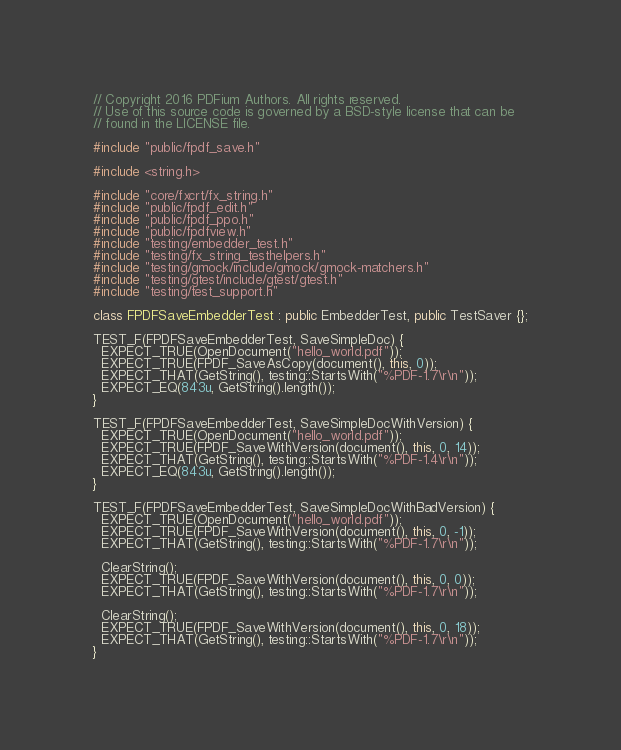<code> <loc_0><loc_0><loc_500><loc_500><_C++_>// Copyright 2016 PDFium Authors. All rights reserved.
// Use of this source code is governed by a BSD-style license that can be
// found in the LICENSE file.

#include "public/fpdf_save.h"

#include <string.h>

#include "core/fxcrt/fx_string.h"
#include "public/fpdf_edit.h"
#include "public/fpdf_ppo.h"
#include "public/fpdfview.h"
#include "testing/embedder_test.h"
#include "testing/fx_string_testhelpers.h"
#include "testing/gmock/include/gmock/gmock-matchers.h"
#include "testing/gtest/include/gtest/gtest.h"
#include "testing/test_support.h"

class FPDFSaveEmbedderTest : public EmbedderTest, public TestSaver {};

TEST_F(FPDFSaveEmbedderTest, SaveSimpleDoc) {
  EXPECT_TRUE(OpenDocument("hello_world.pdf"));
  EXPECT_TRUE(FPDF_SaveAsCopy(document(), this, 0));
  EXPECT_THAT(GetString(), testing::StartsWith("%PDF-1.7\r\n"));
  EXPECT_EQ(843u, GetString().length());
}

TEST_F(FPDFSaveEmbedderTest, SaveSimpleDocWithVersion) {
  EXPECT_TRUE(OpenDocument("hello_world.pdf"));
  EXPECT_TRUE(FPDF_SaveWithVersion(document(), this, 0, 14));
  EXPECT_THAT(GetString(), testing::StartsWith("%PDF-1.4\r\n"));
  EXPECT_EQ(843u, GetString().length());
}

TEST_F(FPDFSaveEmbedderTest, SaveSimpleDocWithBadVersion) {
  EXPECT_TRUE(OpenDocument("hello_world.pdf"));
  EXPECT_TRUE(FPDF_SaveWithVersion(document(), this, 0, -1));
  EXPECT_THAT(GetString(), testing::StartsWith("%PDF-1.7\r\n"));

  ClearString();
  EXPECT_TRUE(FPDF_SaveWithVersion(document(), this, 0, 0));
  EXPECT_THAT(GetString(), testing::StartsWith("%PDF-1.7\r\n"));

  ClearString();
  EXPECT_TRUE(FPDF_SaveWithVersion(document(), this, 0, 18));
  EXPECT_THAT(GetString(), testing::StartsWith("%PDF-1.7\r\n"));
}
</code> 